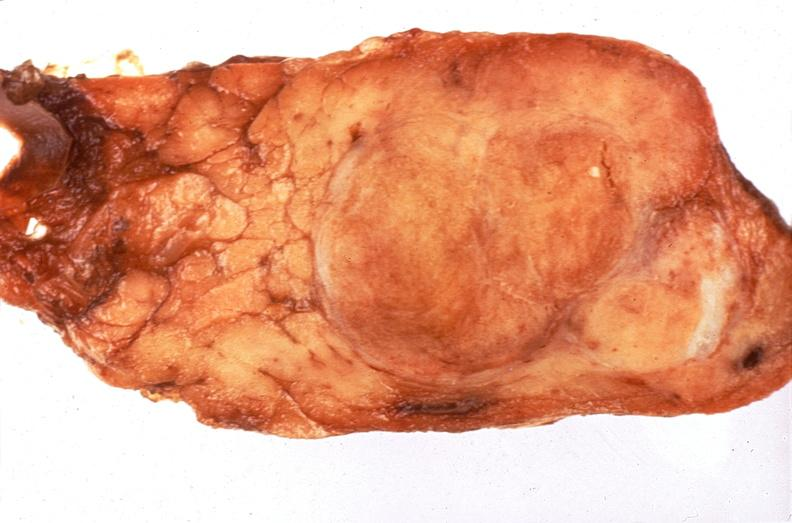s endocrine present?
Answer the question using a single word or phrase. Yes 